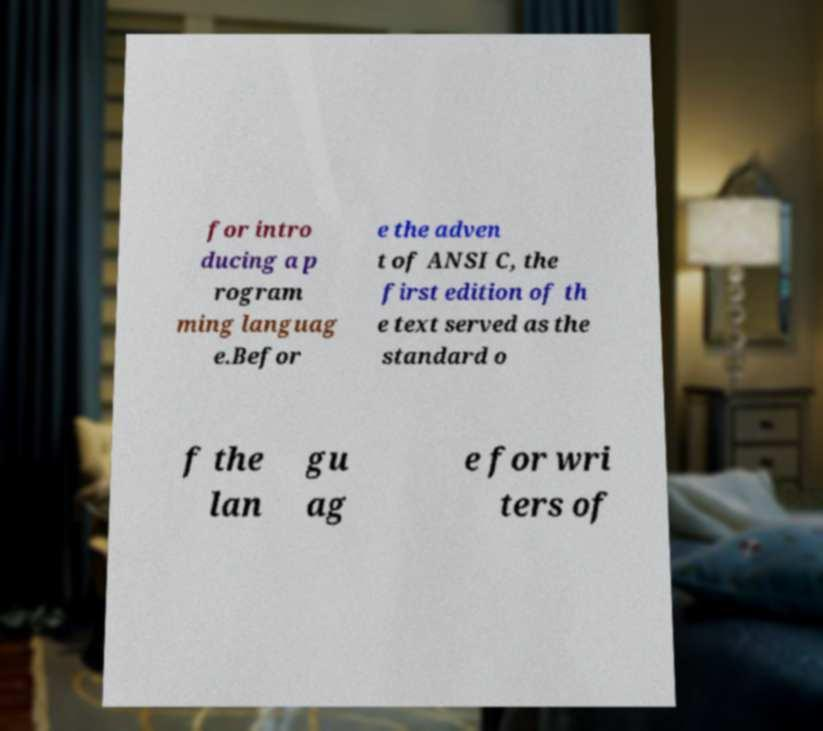For documentation purposes, I need the text within this image transcribed. Could you provide that? for intro ducing a p rogram ming languag e.Befor e the adven t of ANSI C, the first edition of th e text served as the standard o f the lan gu ag e for wri ters of 